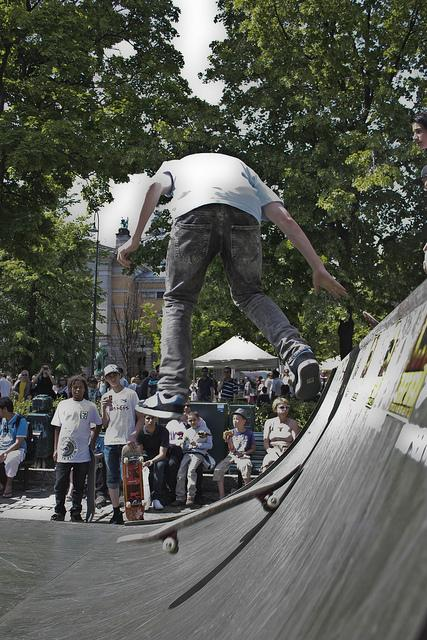Why is he in the air above the skateboard? jumping 